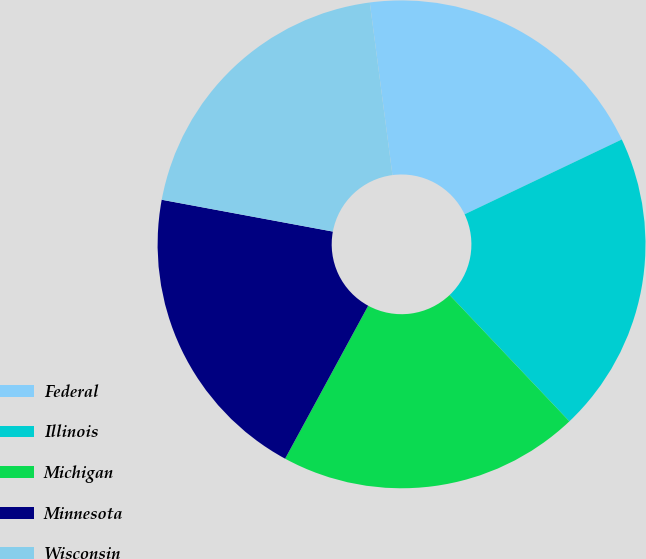Convert chart. <chart><loc_0><loc_0><loc_500><loc_500><pie_chart><fcel>Federal<fcel>Illinois<fcel>Michigan<fcel>Minnesota<fcel>Wisconsin<nl><fcel>20.01%<fcel>20.0%<fcel>20.0%<fcel>20.01%<fcel>20.0%<nl></chart> 